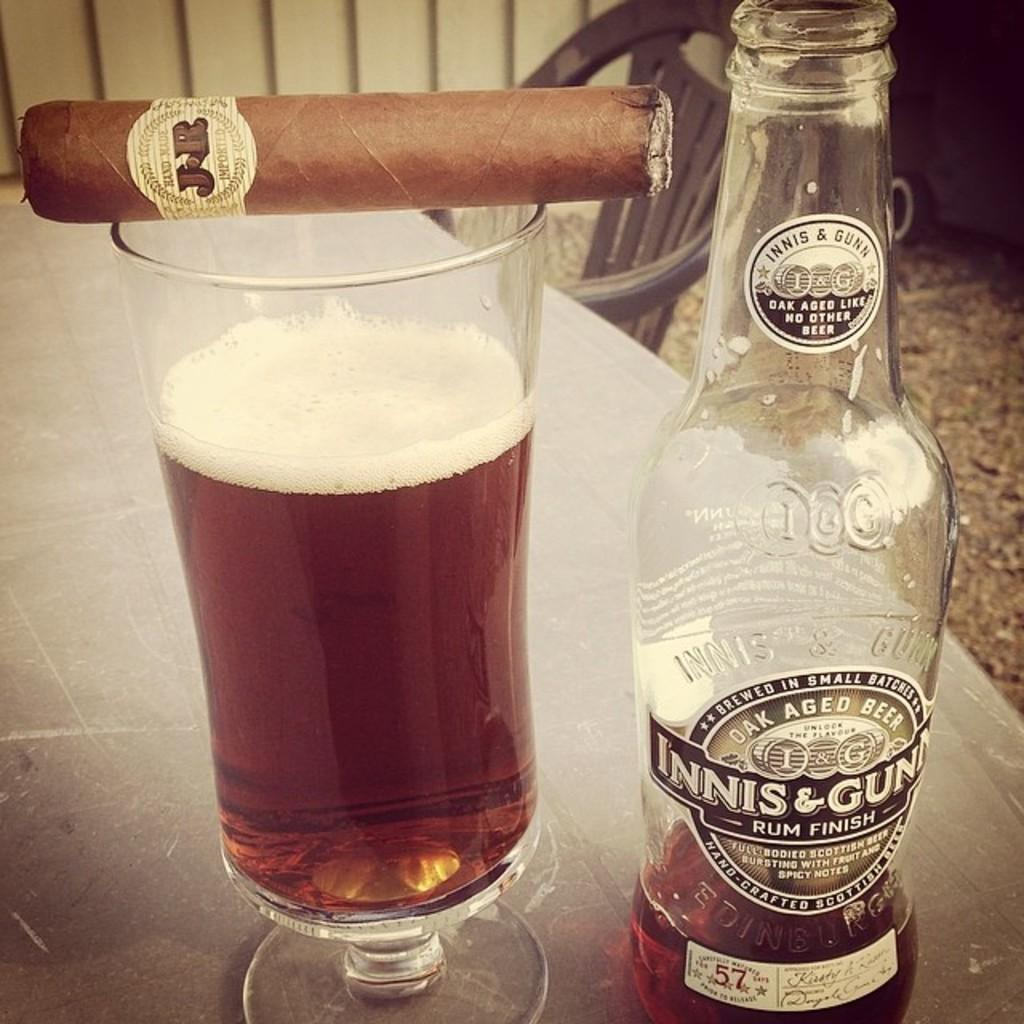<image>
Offer a succinct explanation of the picture presented. A hand-made, imported cigar resting atop a glass of Innis & Gunn beer. 